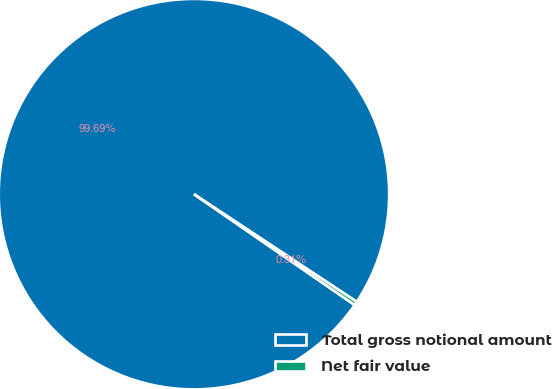Convert chart. <chart><loc_0><loc_0><loc_500><loc_500><pie_chart><fcel>Total gross notional amount<fcel>Net fair value<nl><fcel>99.69%<fcel>0.31%<nl></chart> 